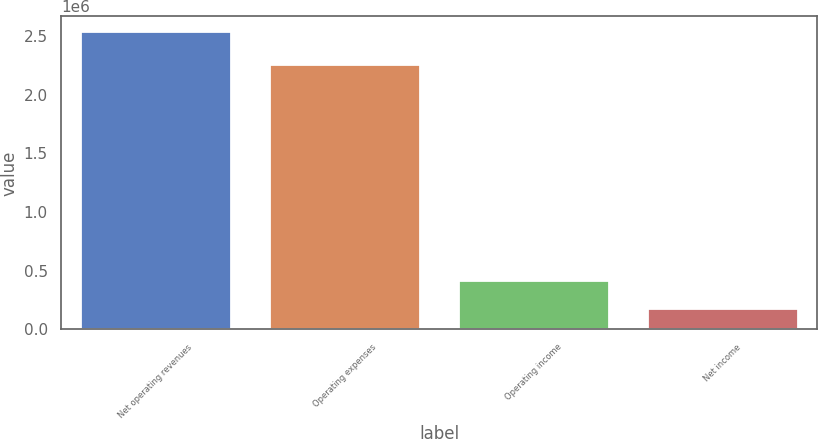<chart> <loc_0><loc_0><loc_500><loc_500><bar_chart><fcel>Net operating revenues<fcel>Operating expenses<fcel>Operating income<fcel>Net income<nl><fcel>2.54193e+06<fcel>2.26323e+06<fcel>415780<fcel>179541<nl></chart> 